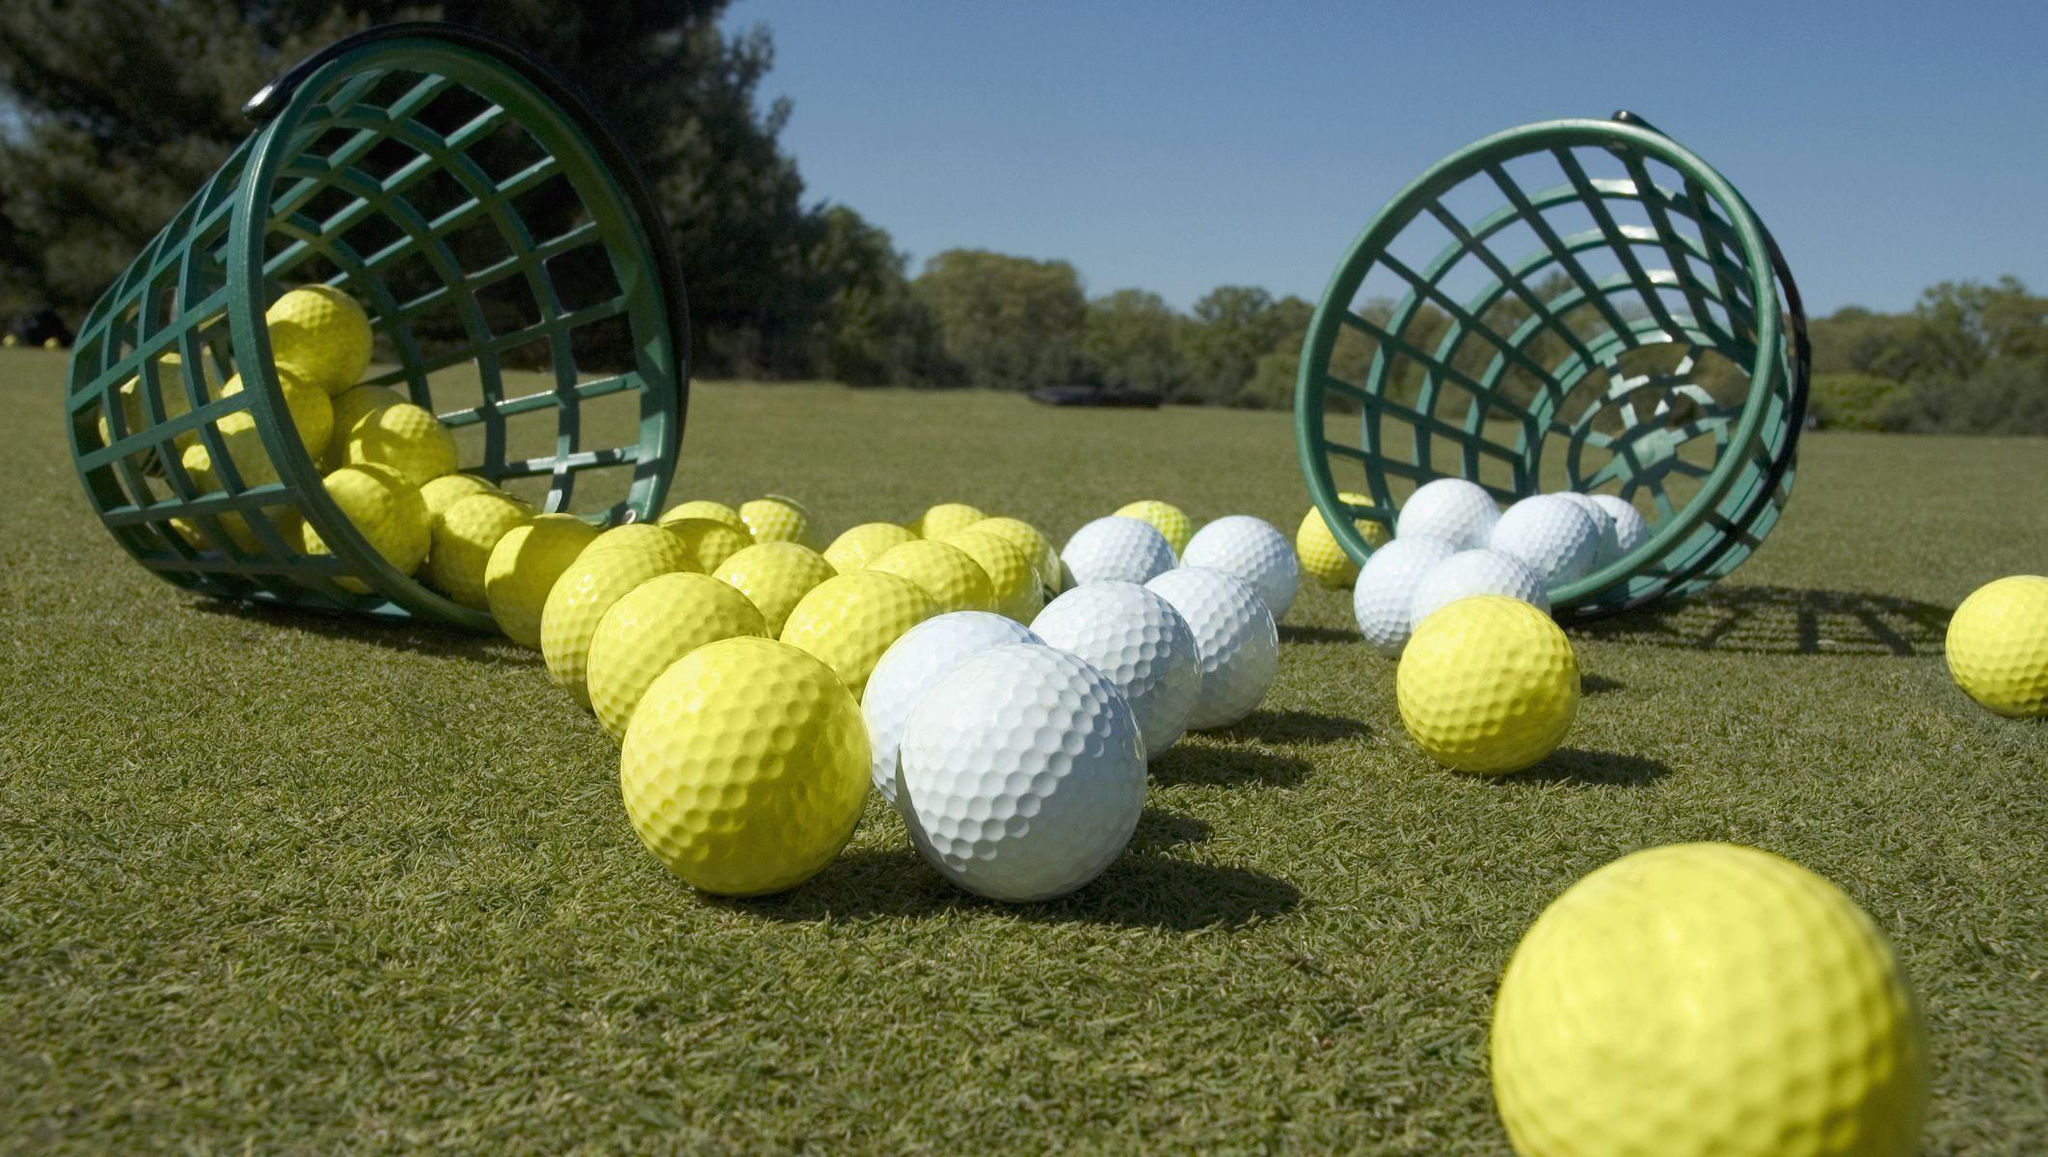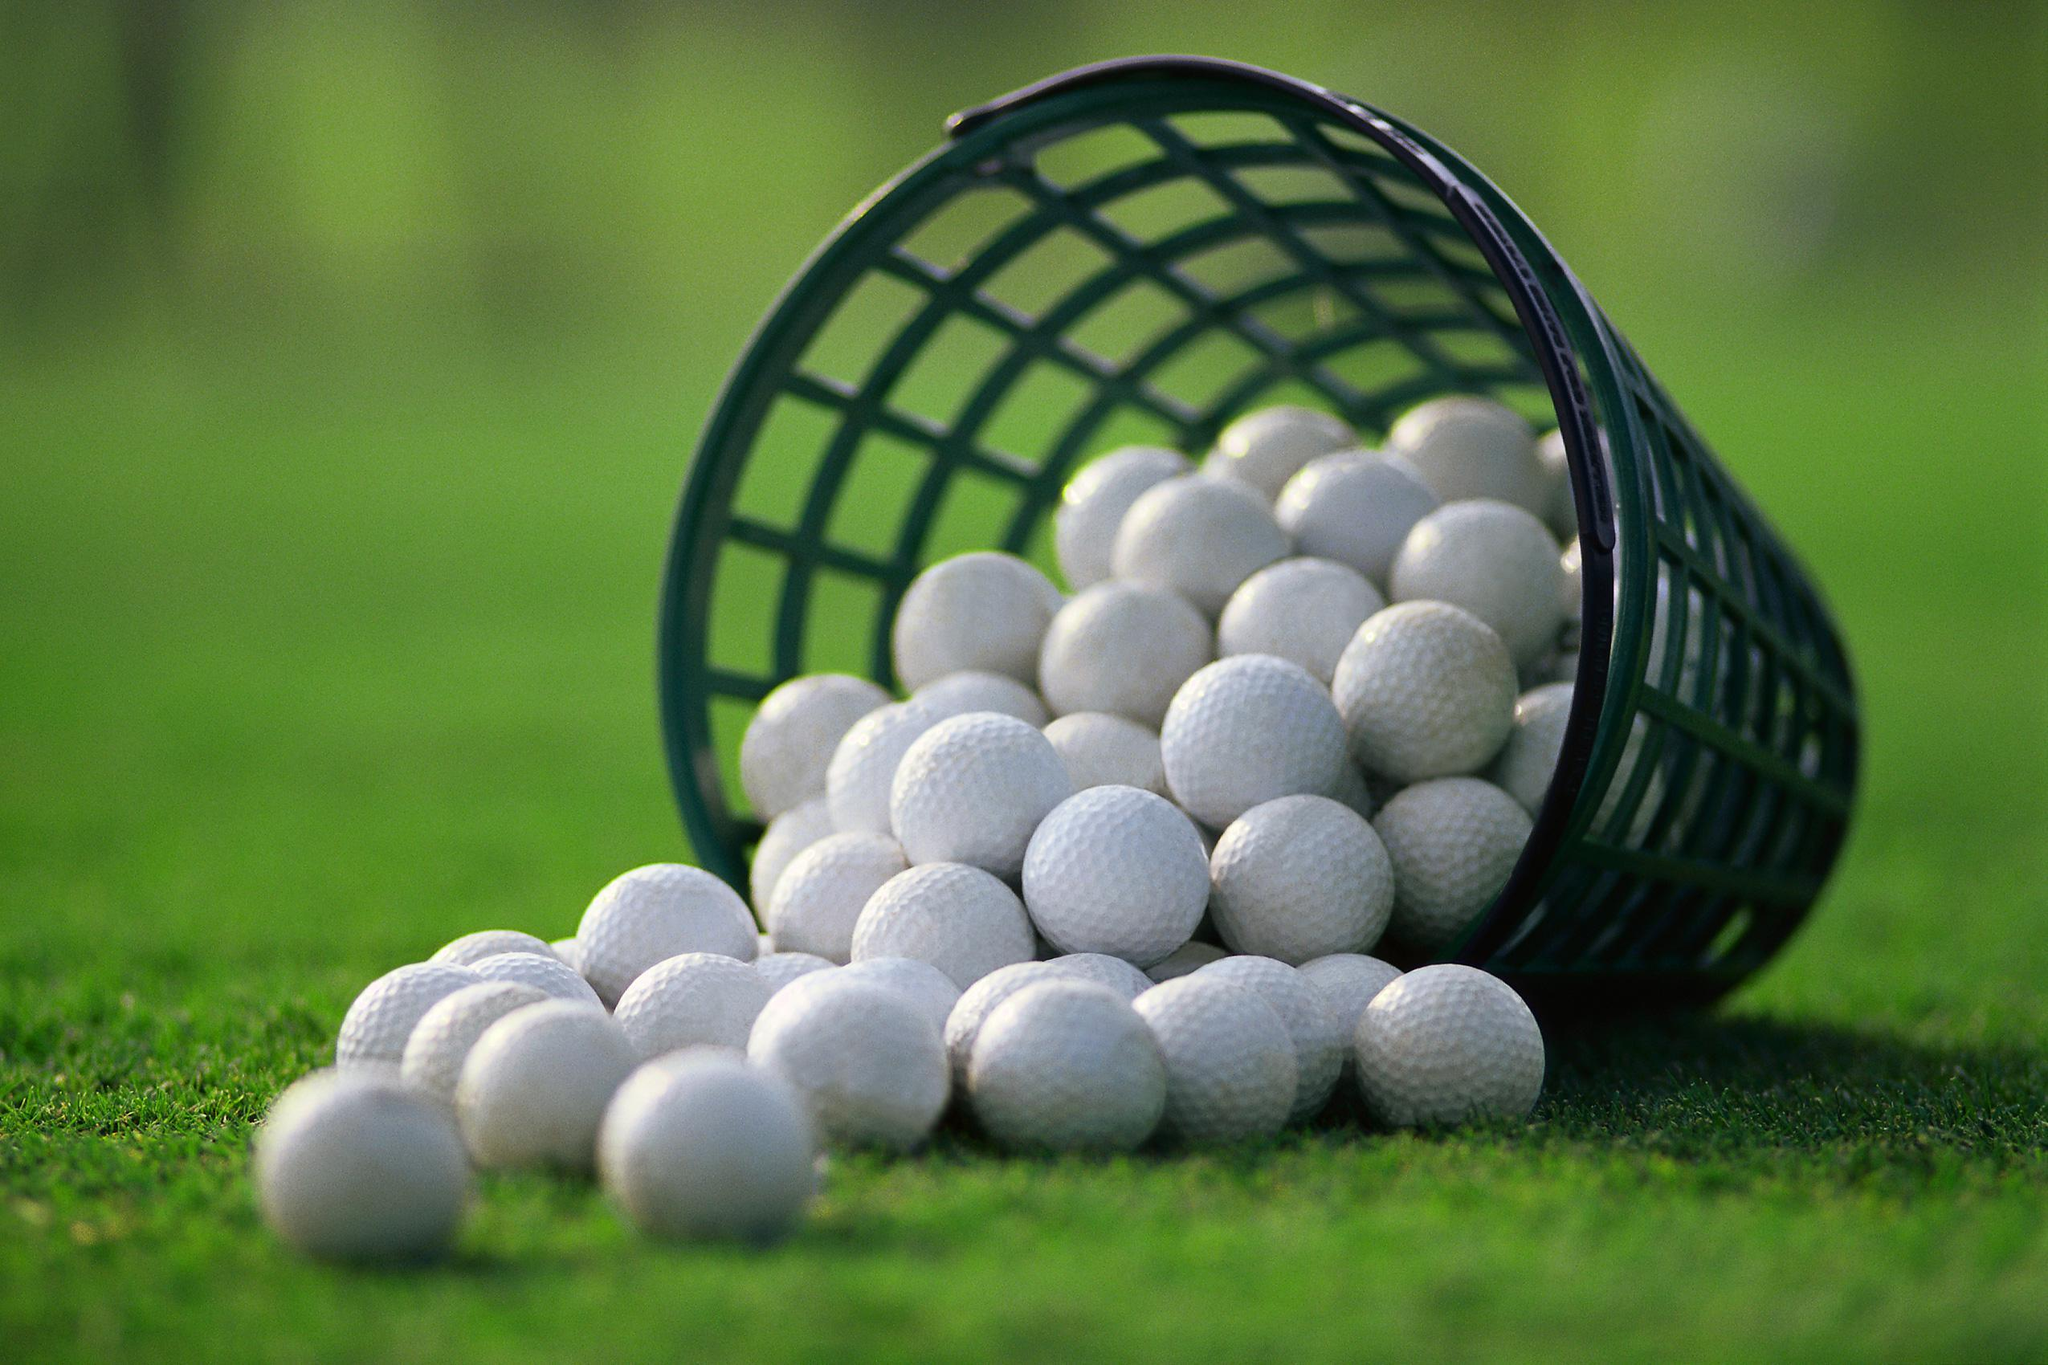The first image is the image on the left, the second image is the image on the right. Evaluate the accuracy of this statement regarding the images: "At least one image shows white golf balls in a mesh-type green basket.". Is it true? Answer yes or no. Yes. The first image is the image on the left, the second image is the image on the right. Analyze the images presented: Is the assertion "At least one pink golf ball can be seen in a large pile of mostly white golf balls in one image." valid? Answer yes or no. No. 